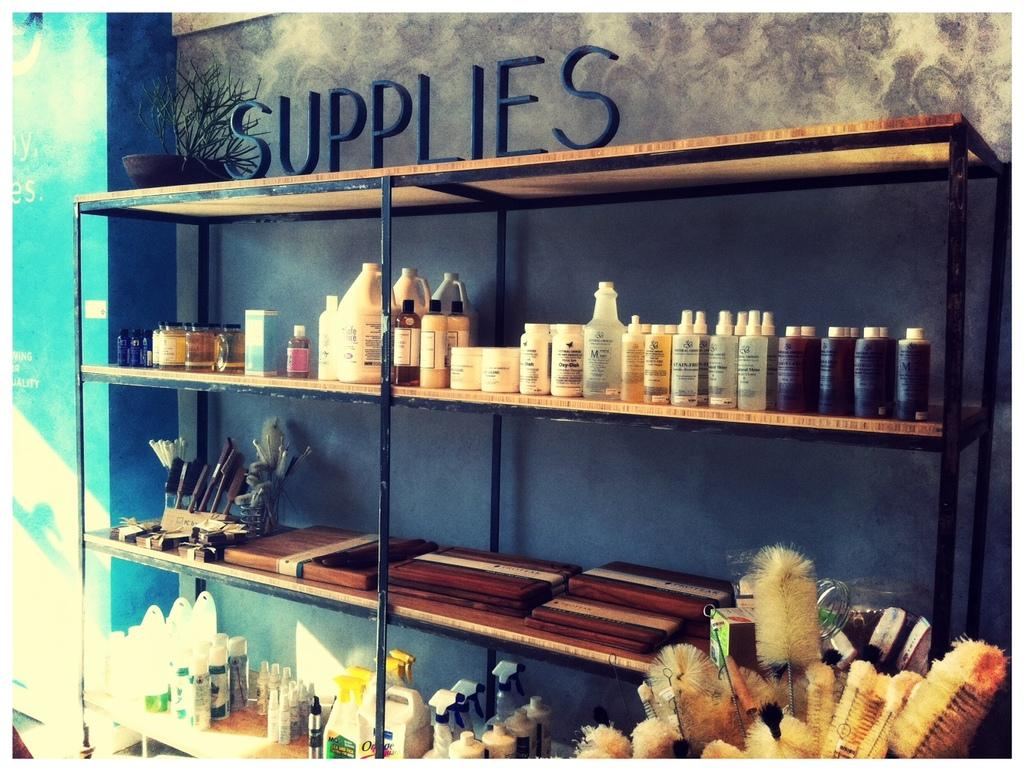<image>
Share a concise interpretation of the image provided. A shelf with various hair care products that says supplies 